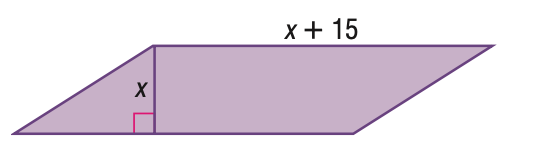Answer the mathemtical geometry problem and directly provide the correct option letter.
Question: Find the base of the parallelogram given its area with 100 square units.
Choices: A: 15 B: 20 C: 25 D: 30 B 